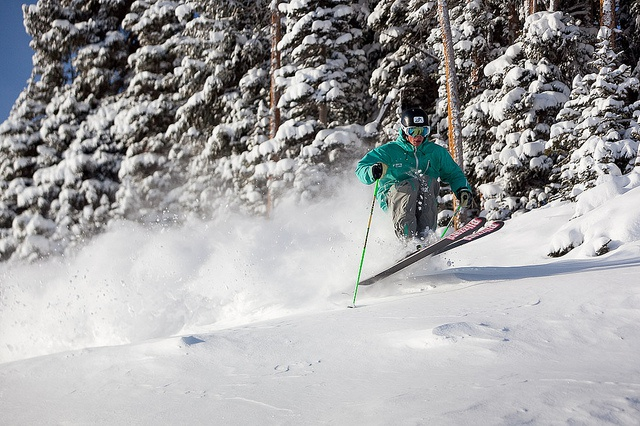Describe the objects in this image and their specific colors. I can see people in blue, teal, black, gray, and darkgray tones and skis in blue, gray, black, lightgray, and darkgray tones in this image. 